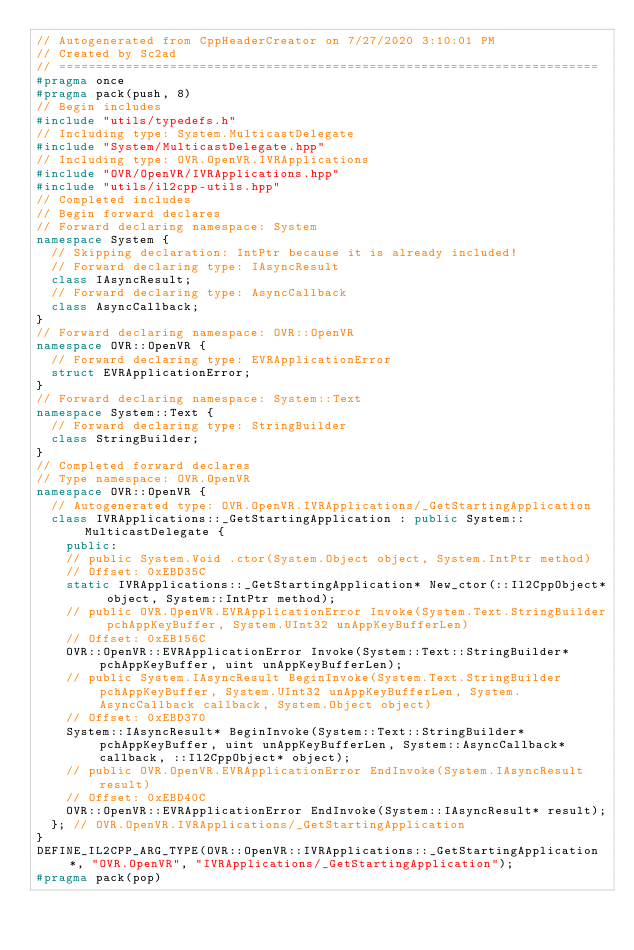Convert code to text. <code><loc_0><loc_0><loc_500><loc_500><_C++_>// Autogenerated from CppHeaderCreator on 7/27/2020 3:10:01 PM
// Created by Sc2ad
// =========================================================================
#pragma once
#pragma pack(push, 8)
// Begin includes
#include "utils/typedefs.h"
// Including type: System.MulticastDelegate
#include "System/MulticastDelegate.hpp"
// Including type: OVR.OpenVR.IVRApplications
#include "OVR/OpenVR/IVRApplications.hpp"
#include "utils/il2cpp-utils.hpp"
// Completed includes
// Begin forward declares
// Forward declaring namespace: System
namespace System {
  // Skipping declaration: IntPtr because it is already included!
  // Forward declaring type: IAsyncResult
  class IAsyncResult;
  // Forward declaring type: AsyncCallback
  class AsyncCallback;
}
// Forward declaring namespace: OVR::OpenVR
namespace OVR::OpenVR {
  // Forward declaring type: EVRApplicationError
  struct EVRApplicationError;
}
// Forward declaring namespace: System::Text
namespace System::Text {
  // Forward declaring type: StringBuilder
  class StringBuilder;
}
// Completed forward declares
// Type namespace: OVR.OpenVR
namespace OVR::OpenVR {
  // Autogenerated type: OVR.OpenVR.IVRApplications/_GetStartingApplication
  class IVRApplications::_GetStartingApplication : public System::MulticastDelegate {
    public:
    // public System.Void .ctor(System.Object object, System.IntPtr method)
    // Offset: 0xEBD35C
    static IVRApplications::_GetStartingApplication* New_ctor(::Il2CppObject* object, System::IntPtr method);
    // public OVR.OpenVR.EVRApplicationError Invoke(System.Text.StringBuilder pchAppKeyBuffer, System.UInt32 unAppKeyBufferLen)
    // Offset: 0xEB156C
    OVR::OpenVR::EVRApplicationError Invoke(System::Text::StringBuilder* pchAppKeyBuffer, uint unAppKeyBufferLen);
    // public System.IAsyncResult BeginInvoke(System.Text.StringBuilder pchAppKeyBuffer, System.UInt32 unAppKeyBufferLen, System.AsyncCallback callback, System.Object object)
    // Offset: 0xEBD370
    System::IAsyncResult* BeginInvoke(System::Text::StringBuilder* pchAppKeyBuffer, uint unAppKeyBufferLen, System::AsyncCallback* callback, ::Il2CppObject* object);
    // public OVR.OpenVR.EVRApplicationError EndInvoke(System.IAsyncResult result)
    // Offset: 0xEBD40C
    OVR::OpenVR::EVRApplicationError EndInvoke(System::IAsyncResult* result);
  }; // OVR.OpenVR.IVRApplications/_GetStartingApplication
}
DEFINE_IL2CPP_ARG_TYPE(OVR::OpenVR::IVRApplications::_GetStartingApplication*, "OVR.OpenVR", "IVRApplications/_GetStartingApplication");
#pragma pack(pop)
</code> 